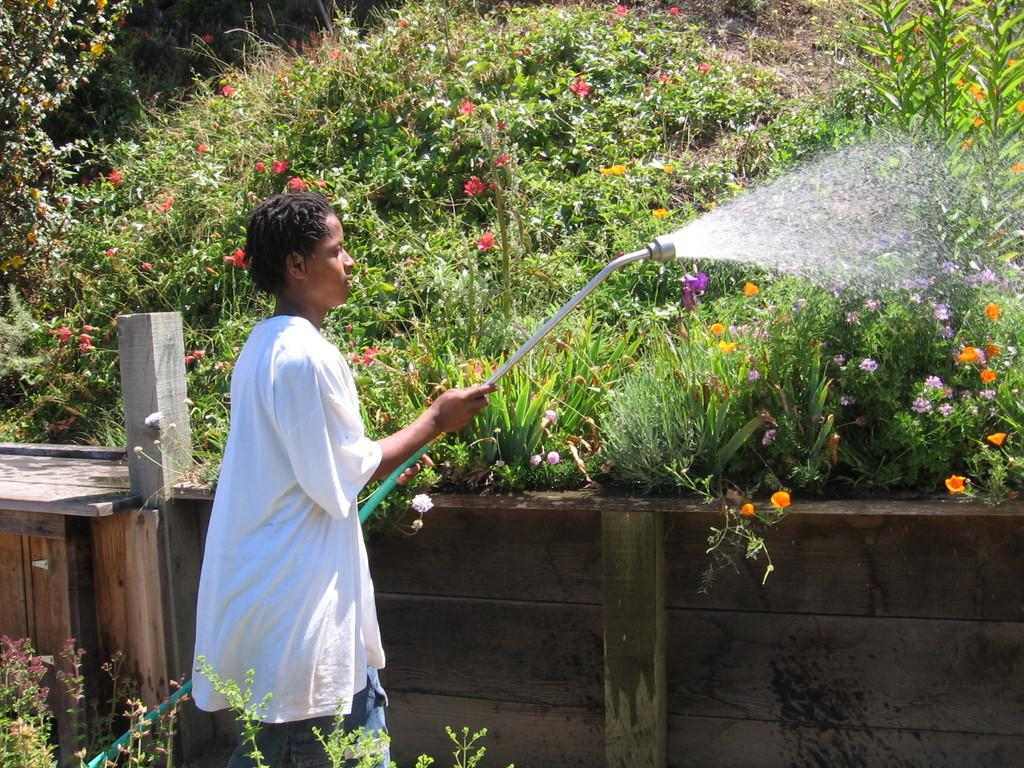What is the person in the image doing? The person is watering plants in the image. What type of plants can be seen in the image? There are plants and flowers in the image. What is the wooden structure in the image? There is a small wooden wall in the image. Can you see a rabbit playing with a doll in the image? No, there is no rabbit or doll present in the image. 